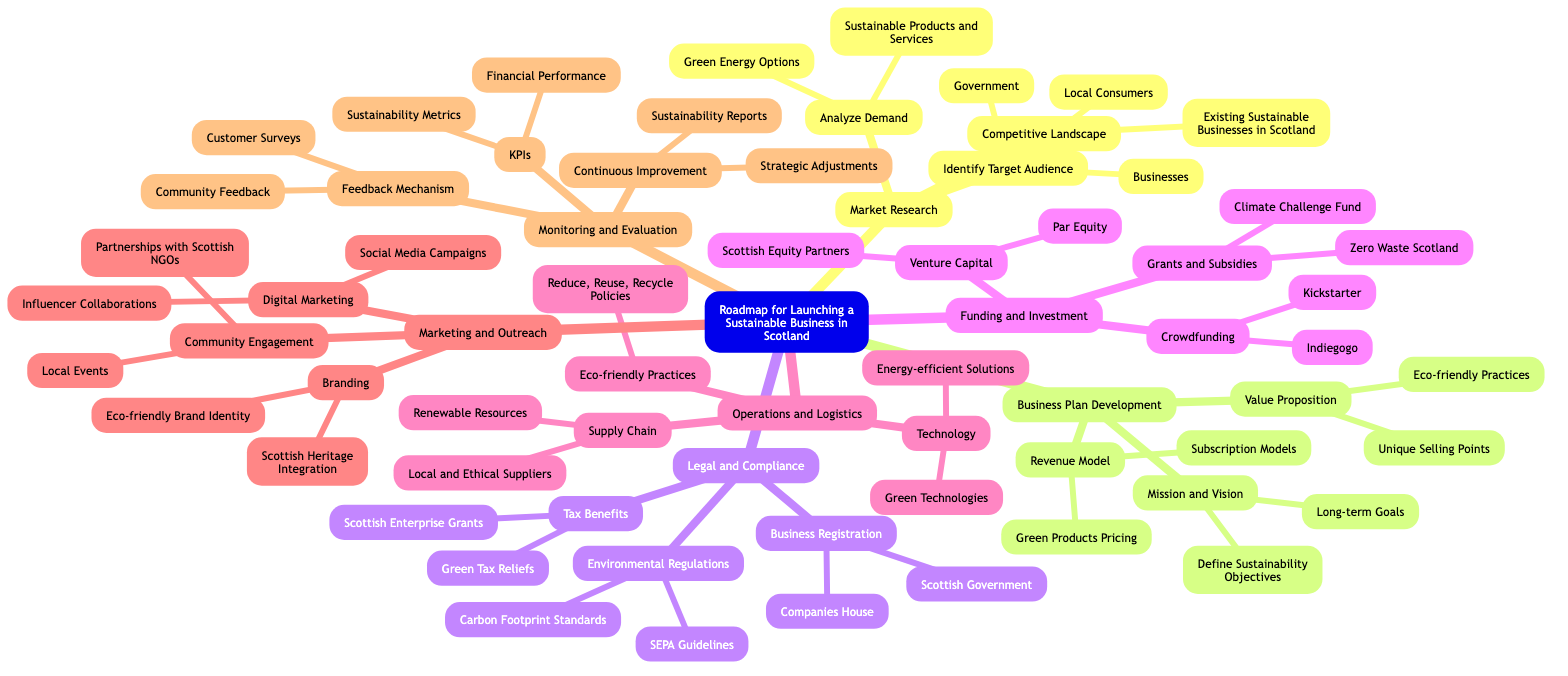What are the three elements of Market Research? The "Market Research" section includes three elements: "Identify Target Audience," "Analyze Demand," and "Competitive Landscape."
Answer: Identify Target Audience, Analyze Demand, Competitive Landscape How many elements are included in Business Plan Development? The "Business Plan Development" section contains three elements: "Mission and Vision," "Value Proposition," and "Revenue Model."
Answer: 3 What organization is responsible for Business Registration in Scotland? Under the "Legal and Compliance" section, the organization responsible for Business Registration is "Companies House."
Answer: Companies House Which funding option falls under Grants and Subsidies? In the "Funding and Investment" section, "Zero Waste Scotland" is listed as an option under Grants and Subsidies.
Answer: Zero Waste Scotland List one technology mentioned in Operations and Logistics. The "Operations and Logistics" section lists "Green Technologies" as one of the technologies mentioned for sustainable business operations.
Answer: Green Technologies What KPIs are suggested for Monitoring and Evaluation? The "Monitoring and Evaluation" section suggests "Sustainability Metrics" and "Financial Performance" as relevant KPIs.
Answer: Sustainability Metrics, Financial Performance Explain the relationship between Marketing and Outreach and Community Engagement. "Marketing and Outreach" contains the element "Community Engagement," which aims to enhance local connections and awareness of the business. This implies that Community Engagement is a component of the broader Marketing and Outreach strategy.
Answer: Community Engagement is part of Marketing and Outreach Which two sources of Venture Capital are listed? Within the "Funding and Investment" category, the two sources of Venture Capital listed are "Scottish Equity Partners" and "Par Equity."
Answer: Scottish Equity Partners, Par Equity What is a key focus of Legal and Compliance in relation to Environmental Regulations? The key focus in the "Legal and Compliance" section related to Environmental Regulations includes adhering to "SEPA Guidelines" and "Carbon Footprint Standards."
Answer: SEPA Guidelines, Carbon Footprint Standards 